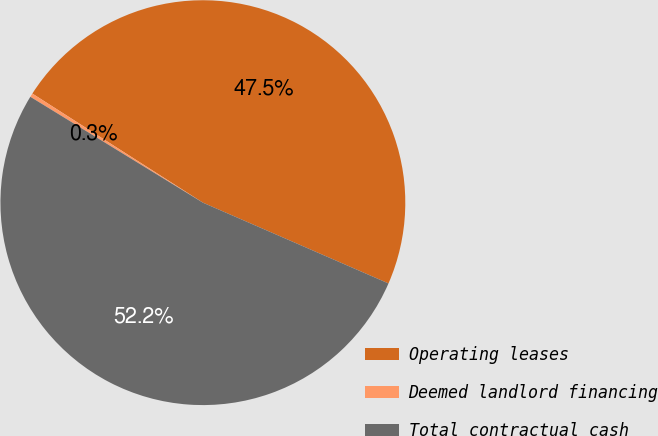Convert chart. <chart><loc_0><loc_0><loc_500><loc_500><pie_chart><fcel>Operating leases<fcel>Deemed landlord financing<fcel>Total contractual cash<nl><fcel>47.48%<fcel>0.3%<fcel>52.23%<nl></chart> 